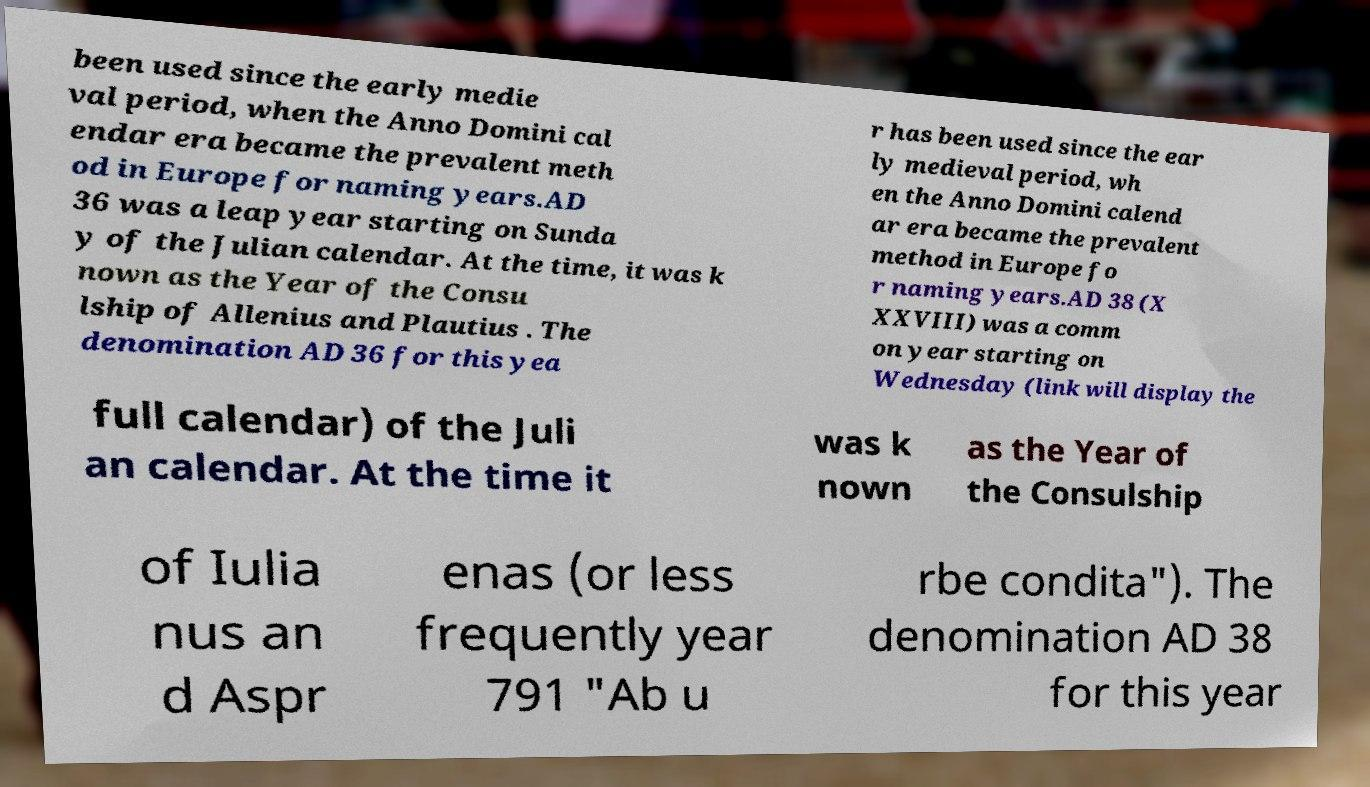Could you assist in decoding the text presented in this image and type it out clearly? been used since the early medie val period, when the Anno Domini cal endar era became the prevalent meth od in Europe for naming years.AD 36 was a leap year starting on Sunda y of the Julian calendar. At the time, it was k nown as the Year of the Consu lship of Allenius and Plautius . The denomination AD 36 for this yea r has been used since the ear ly medieval period, wh en the Anno Domini calend ar era became the prevalent method in Europe fo r naming years.AD 38 (X XXVIII) was a comm on year starting on Wednesday (link will display the full calendar) of the Juli an calendar. At the time it was k nown as the Year of the Consulship of Iulia nus an d Aspr enas (or less frequently year 791 "Ab u rbe condita"). The denomination AD 38 for this year 